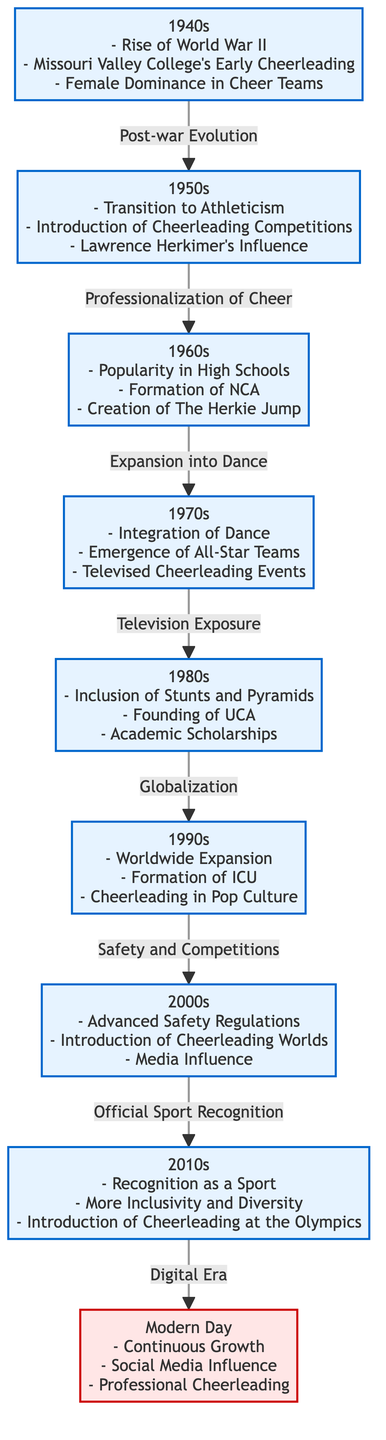What decade marked the rise of World War II and Missouri Valley College's early cheerleading? The diagram identifies the 1940s as the decade that experienced the rise of World War II and also highlights Missouri Valley College's early cheerleading.
Answer: 1940s Which decade introduced cheerleading competitions? The diagram indicates that the 1950s marked the introduction of cheerleading competitions, showing a key development in the evolution of the sport during that time.
Answer: 1950s What was established in the 1960s that contributed to the popularity of cheerleading? According to the diagram, the establishment of the National Cheerleaders Association (NCA) in the 1960s significantly contributed to the popularity of cheerleading, indicating a formalization of the sport.
Answer: NCA How did the 1970s influence the evolution of cheerleading? The 1970s influenced cheerleading with the integration of dance and the emergence of all-star teams, as noted in the diagram, highlighting a diversification of cheerleading styles and teams.
Answer: Dance and All-Star Teams Which decade saw the introduction of advanced safety regulations? The diagram specifies that the 2000s were the decade that introduced advanced safety regulations in cheerleading, reflecting an internal effort to enhance safety within the sport.
Answer: 2000s What is a notable achievement of the 2010s as shown in the diagram? The 2010s is notably recognized for the official recognition of cheerleading as a sport, a key milestone illustrating the growing legitimacy of cheerleading in athletic contexts.
Answer: Recognition as a Sport What links the 1980s to the 1990s according to the diagram? The diagram shows that globalization in the 1980s leads to the worldwide expansion of cheerleading in the 1990s, demonstrating an important transition between these decades.
Answer: Globalization What is a key influence from the modern day of cheerleading? In the modern day, social media influence is a key aspect noted in the diagram, indicating how contemporary platforms affect cheerleading culture and promotion.
Answer: Social Media Influence 